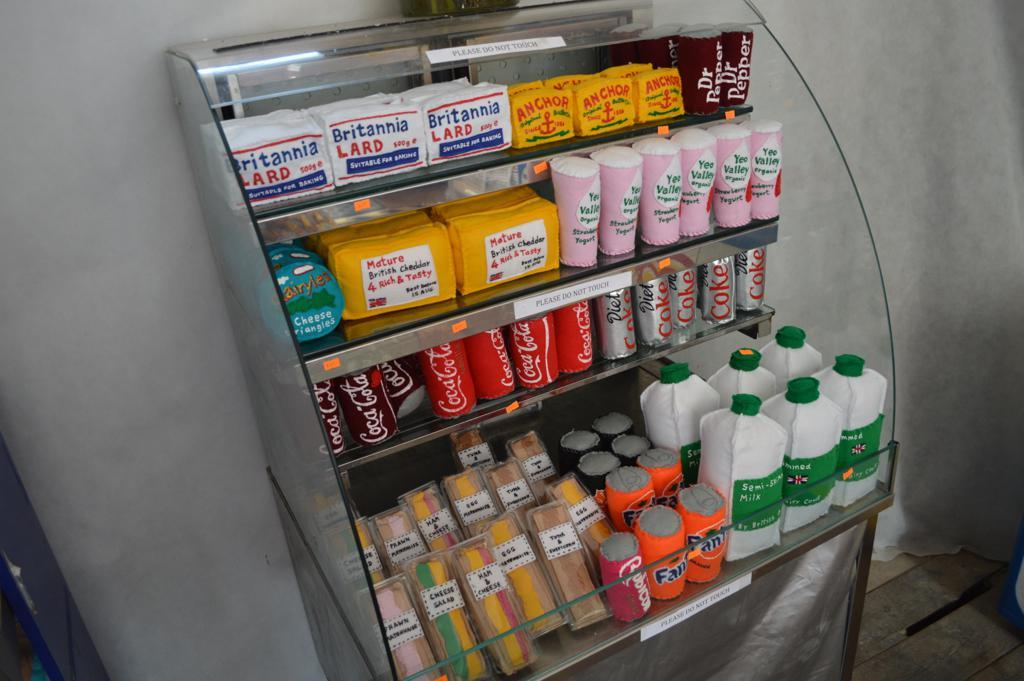<image>
Provide a brief description of the given image. A variety of products in a fridge including mature British Cheddar, and Fanta among other products. 